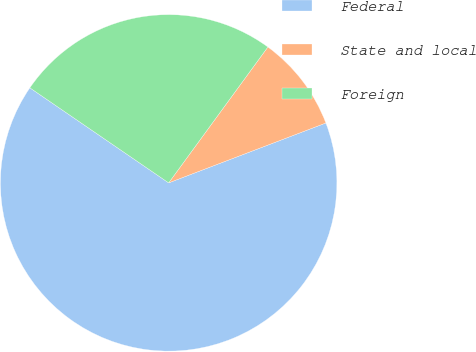<chart> <loc_0><loc_0><loc_500><loc_500><pie_chart><fcel>Federal<fcel>State and local<fcel>Foreign<nl><fcel>65.35%<fcel>9.17%<fcel>25.48%<nl></chart> 